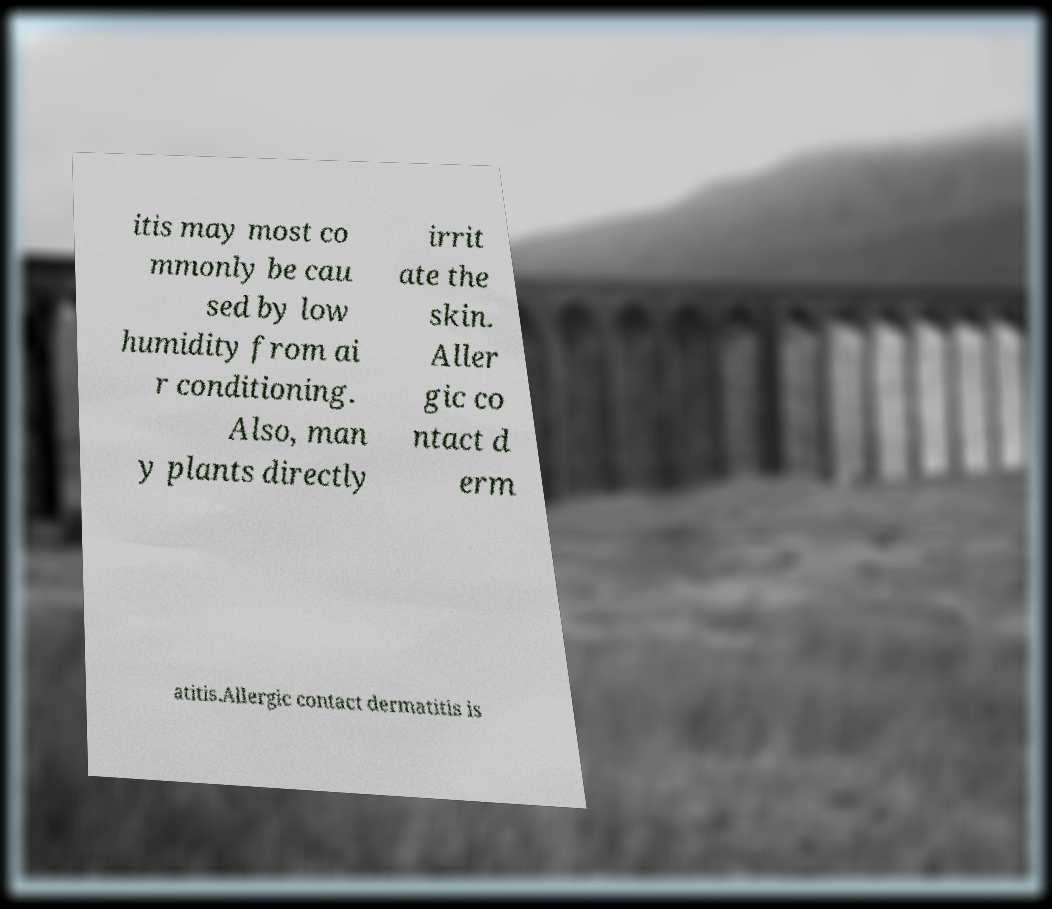Could you extract and type out the text from this image? itis may most co mmonly be cau sed by low humidity from ai r conditioning. Also, man y plants directly irrit ate the skin. Aller gic co ntact d erm atitis.Allergic contact dermatitis is 